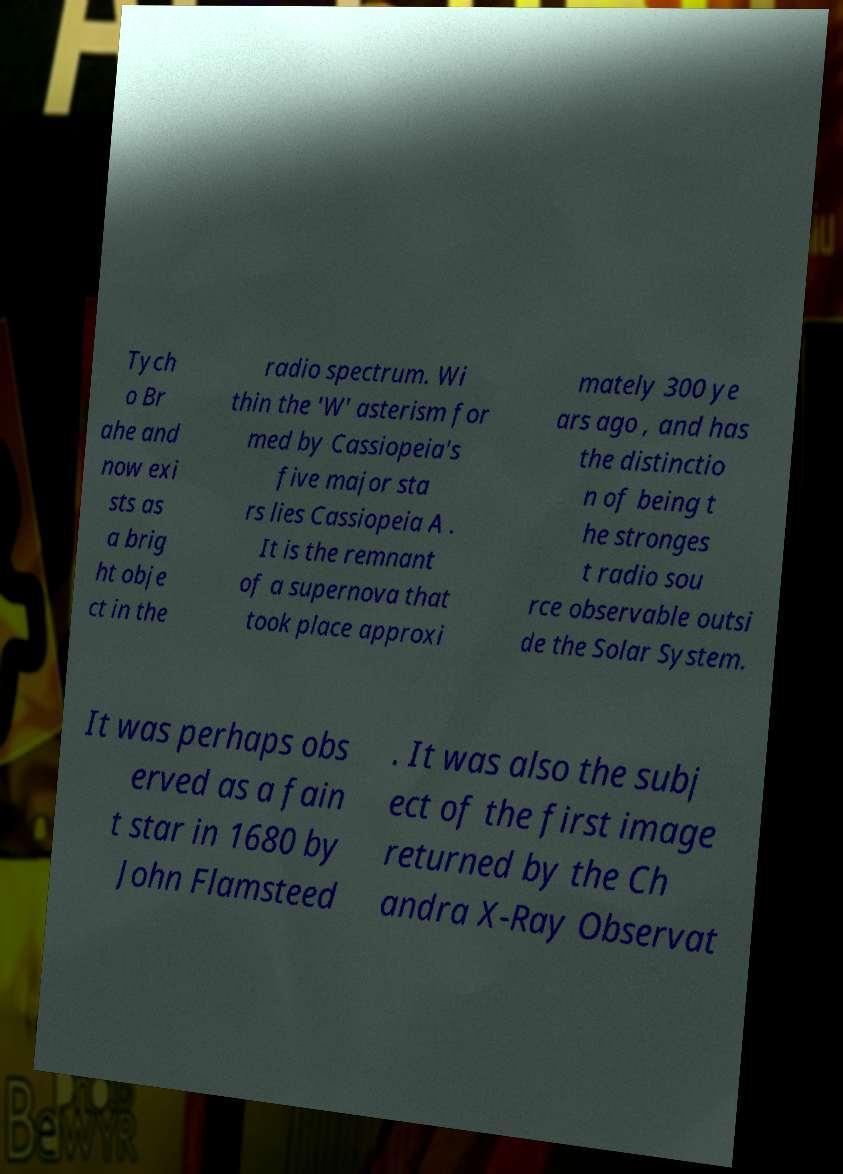Please identify and transcribe the text found in this image. Tych o Br ahe and now exi sts as a brig ht obje ct in the radio spectrum. Wi thin the 'W' asterism for med by Cassiopeia's five major sta rs lies Cassiopeia A . It is the remnant of a supernova that took place approxi mately 300 ye ars ago , and has the distinctio n of being t he stronges t radio sou rce observable outsi de the Solar System. It was perhaps obs erved as a fain t star in 1680 by John Flamsteed . It was also the subj ect of the first image returned by the Ch andra X-Ray Observat 